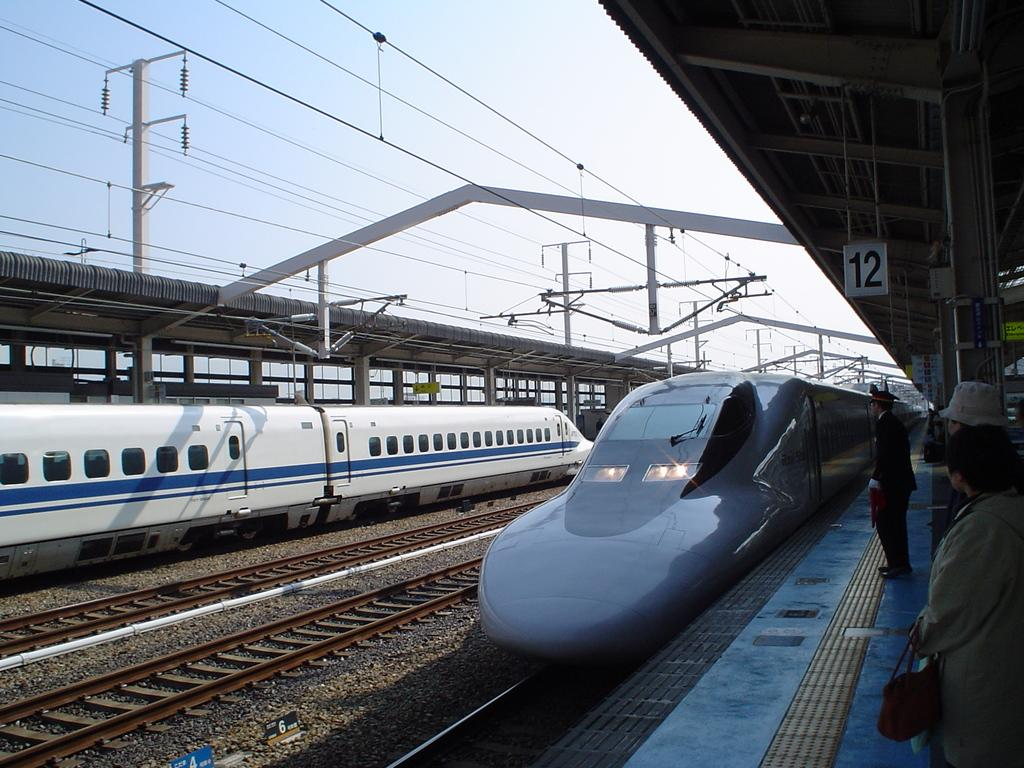What is the main feature of the image? There is a train track in the image. What is moving along the train track? There are two trains on the train track. What else can be seen in the image besides the train track and trains? There are wires visible in the image. Are there any people in the image? Yes, there are people on the floor in the image. What type of bushes can be seen growing near the train track in the image? There are no bushes visible in the image; the focus is on the train track, trains, wires, and people. 